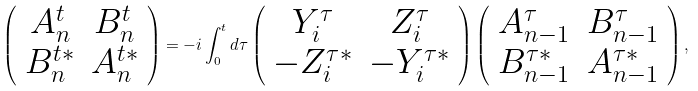Convert formula to latex. <formula><loc_0><loc_0><loc_500><loc_500>\left ( \begin{array} { c c } A ^ { t } _ { n } & B ^ { t } _ { n } \\ B ^ { t * } _ { n } & A ^ { t * } _ { n } \end{array} \right ) = - i \int _ { 0 } ^ { t } d \tau \left ( \begin{array} { c c } Y ^ { \tau } _ { i } & Z ^ { \tau } _ { i } \\ - Z ^ { \tau * } _ { i } & - Y ^ { \tau * } _ { i } \end{array} \right ) \left ( \begin{array} { c c } A ^ { \tau } _ { n - 1 } & B ^ { \tau } _ { n - 1 } \\ B ^ { \tau * } _ { n - 1 } & A ^ { \tau * } _ { n - 1 } \end{array} \right ) ,</formula> 